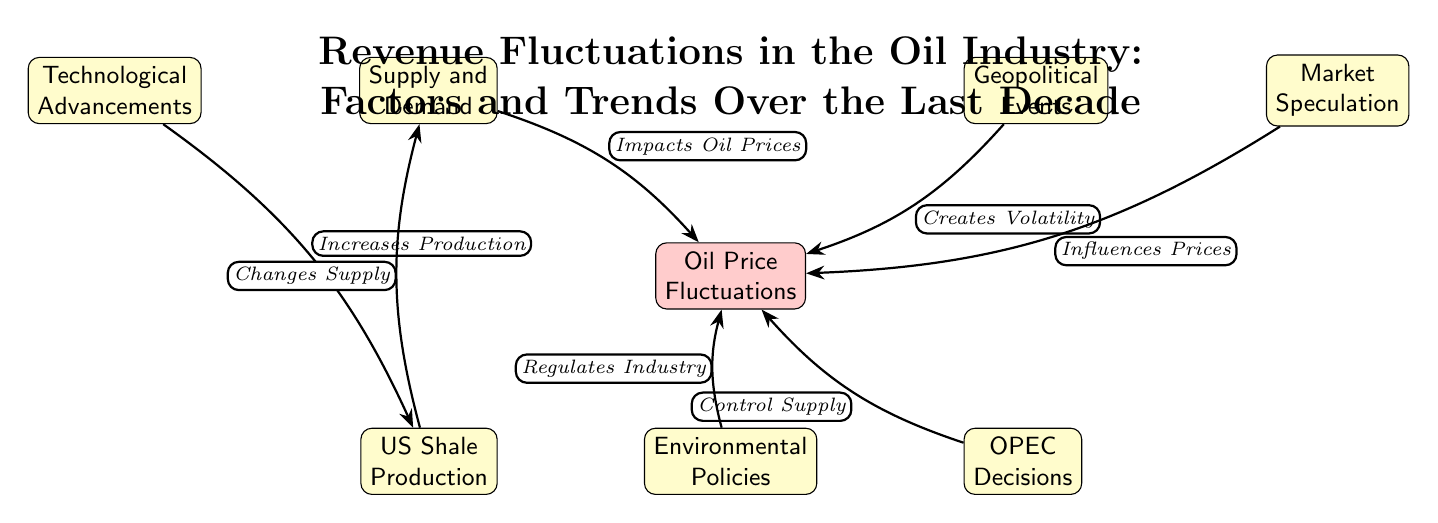What are the two main factors that impact oil prices? The diagram indicates the factors that influence oil prices include "Supply and Demand" and "Geopolitical Events." These are the two nodes directly connected to "Oil Price Fluctuations."
Answer: Supply and Demand, Geopolitical Events How many nodes are depicted in the diagram? The diagram contains a total of seven nodes: "Oil Price Fluctuations," "Supply and Demand," "Geopolitical Events," "OPEC Decisions," "Technological Advancements," "Market Speculation," "US Shale Production," and "Environmental Policies." Counting these gives us a total of seven nodes.
Answer: 7 Which factor is indicated to regulate the oil industry? According to the diagram, "Environmental Policies" is the node that is described as "Regulates Industry," indicating that it plays a role in the regulation of the oil industry.
Answer: Environmental Policies What connection directly influences the change in supply? The connection from "US Shale Production" to "Supply and Demand" is specified as "Changes Supply," indicating it directly influences supply levels within the market.
Answer: Changes Supply Which node influences prices through market behavior? The node "Market Speculation" is connected to "Oil Price Fluctuations" with the edge labeled "Influences Prices," which shows its role in affecting oil prices through speculation in the market.
Answer: Influences Prices What is the relationship between "Technological Advancements" and "US Shale Production"? The diagram shows that "Technological Advancements" increases production in "US Shale Production," highlighting a positive relationship between advancements in technology and shale production levels.
Answer: Increases Production How do OPEC decisions affect oil prices? The edge labeled "Control Supply" between "OPEC Decisions" and "Oil Price Fluctuations" denotes that OPEC's decisions are aimed at controlling the supply of oil, which directly impacts its prices.
Answer: Control Supply What element creates volatility in oil prices? The diagram indicates that "Geopolitical Events" create volatility, as it is directly linked to "Oil Price Fluctuations" with the edge labeled "Creates Volatility."
Answer: Creates Volatility Which factor both influences oil prices and changes supply? "US Shale Production" is unique in the diagram as it informs both "Supply and Demand" directly through "Changes Supply," as well as influencing "Oil Price Fluctuations" through its contribution to supply.
Answer: US Shale Production 